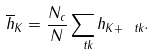Convert formula to latex. <formula><loc_0><loc_0><loc_500><loc_500>\overline { h } _ { K } = \frac { N _ { c } } { N } \sum _ { \ t k } h _ { K + \ t k } .</formula> 